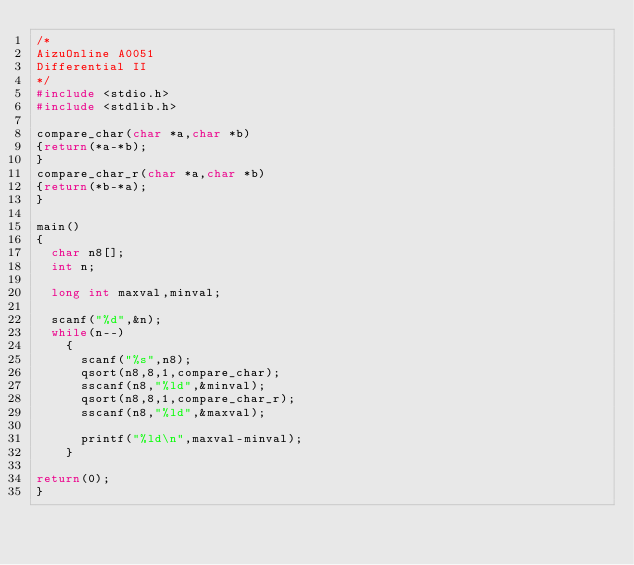Convert code to text. <code><loc_0><loc_0><loc_500><loc_500><_C_>/*
AizuOnline A0051
Differential II
*/
#include <stdio.h>
#include <stdlib.h>

compare_char(char *a,char *b)
{return(*a-*b);
}
compare_char_r(char *a,char *b)
{return(*b-*a);
}

main()
{
  char n8[];
  int n;
  
  long int maxval,minval;

  scanf("%d",&n);
  while(n--)
    {
      scanf("%s",n8);
      qsort(n8,8,1,compare_char);
      sscanf(n8,"%ld",&minval);
      qsort(n8,8,1,compare_char_r);
      sscanf(n8,"%ld",&maxval);

      printf("%ld\n",maxval-minval);
    }

return(0);
}</code> 